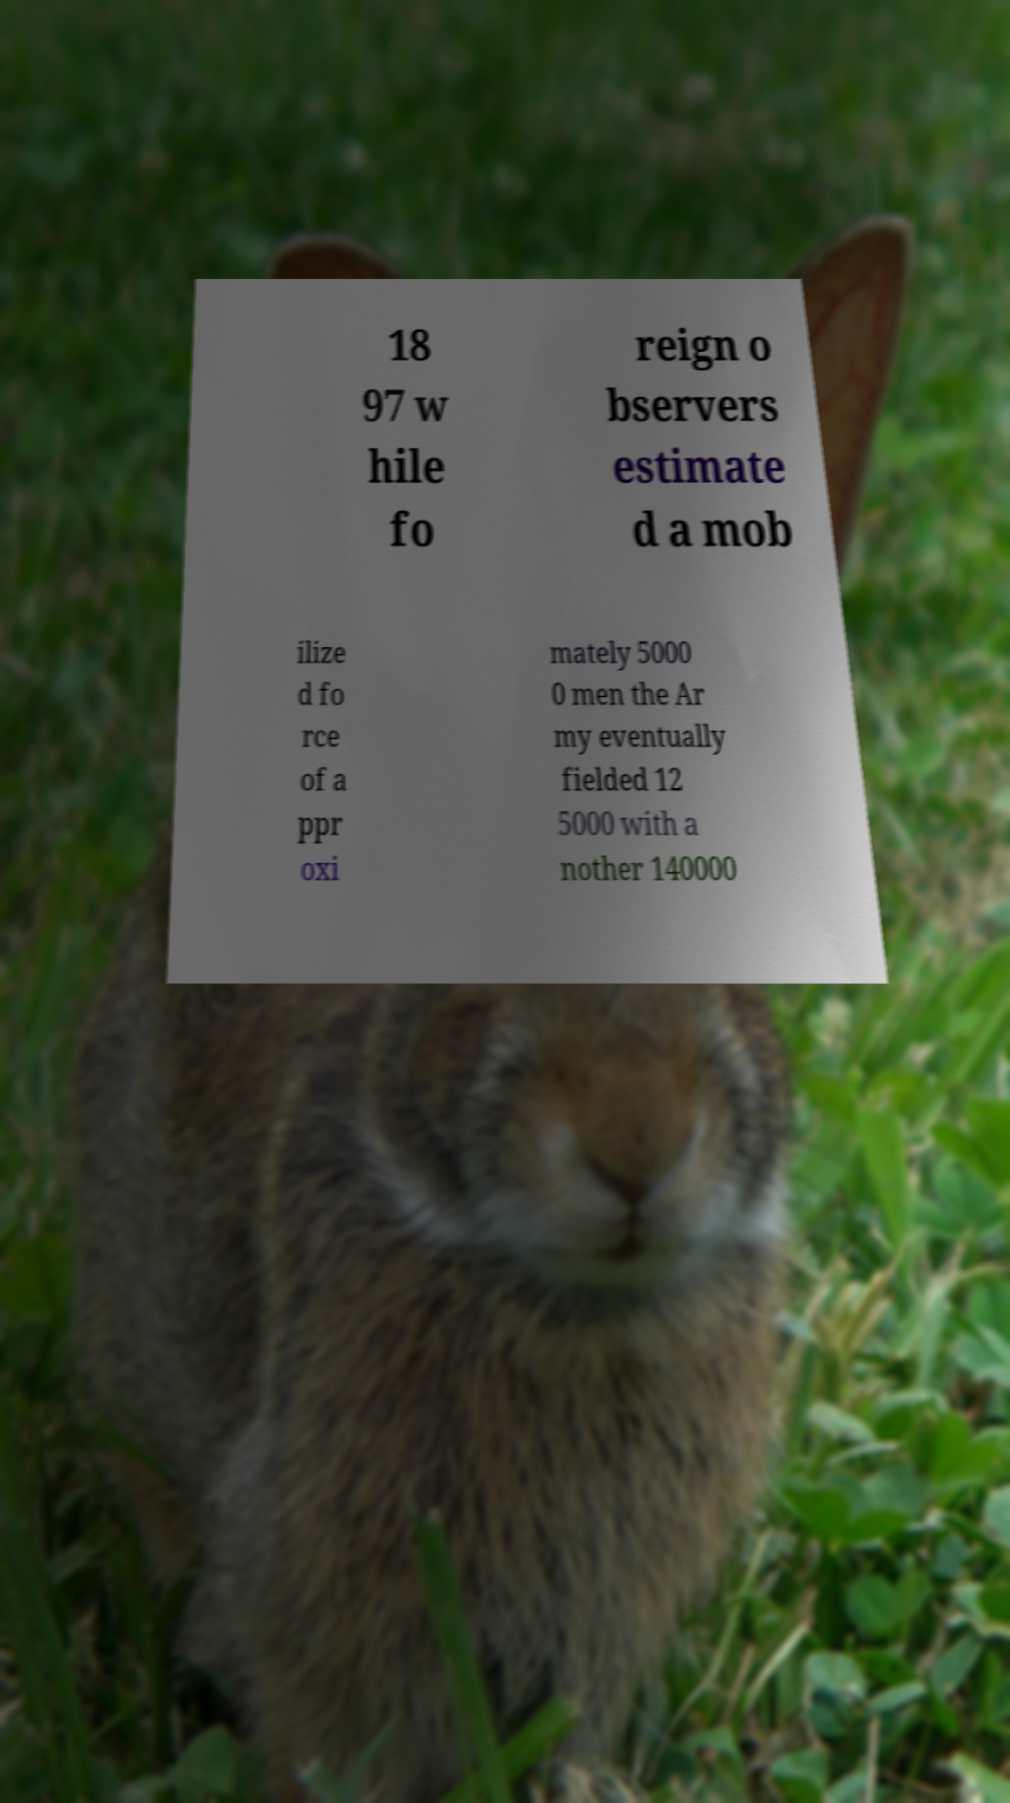Please read and relay the text visible in this image. What does it say? 18 97 w hile fo reign o bservers estimate d a mob ilize d fo rce of a ppr oxi mately 5000 0 men the Ar my eventually fielded 12 5000 with a nother 140000 